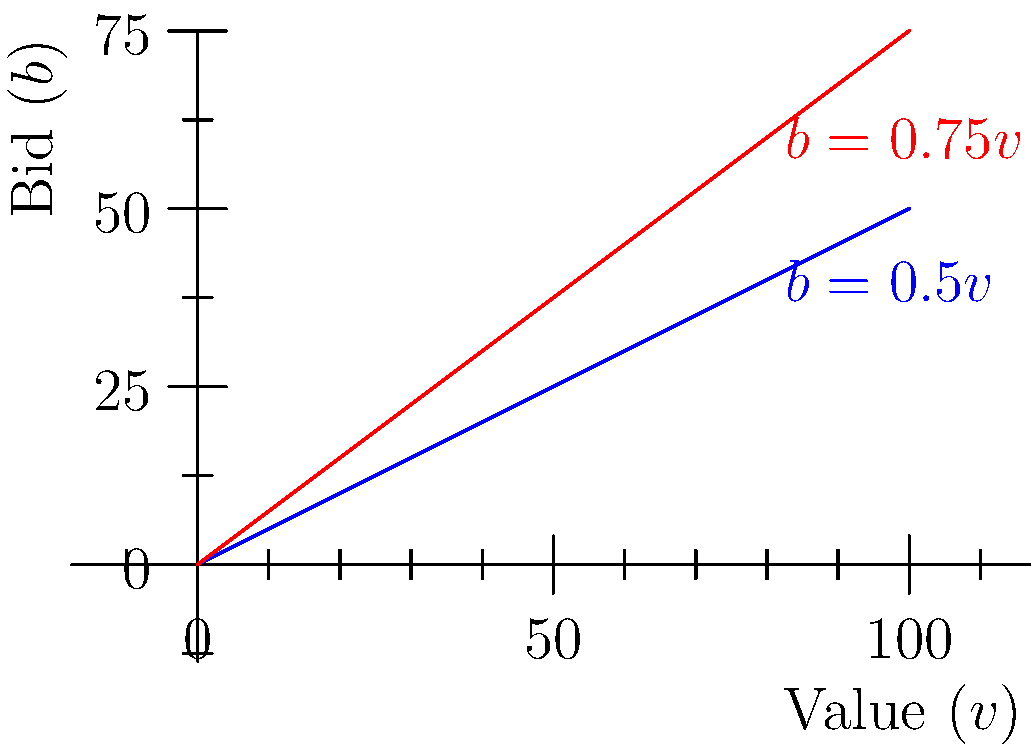Consider the graph showing bid functions for first-price and second-price auctions. If a bidder's true value for an item is $80, what is the difference between their optimal bids in the second-price auction versus the first-price auction? To solve this problem, we need to follow these steps:

1. Identify the bid functions:
   - First-price auction (blue line): $b = 0.5v$
   - Second-price auction (red line): $b = 0.75v$

2. Calculate the optimal bid for the first-price auction:
   $b_1 = 0.5v = 0.5 \times 80 = 40$

3. Calculate the optimal bid for the second-price auction:
   $b_2 = 0.75v = 0.75 \times 80 = 60$

4. Calculate the difference between the two bids:
   $\text{Difference} = b_2 - b_1 = 60 - 40 = 20$

The difference between the optimal bids in the second-price auction versus the first-price auction is 20.
Answer: $20 